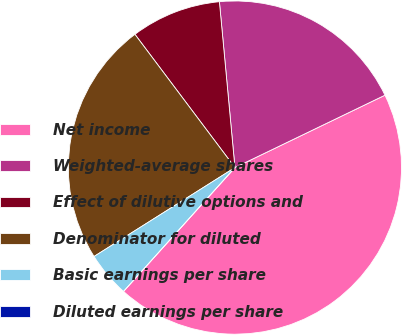Convert chart. <chart><loc_0><loc_0><loc_500><loc_500><pie_chart><fcel>Net income<fcel>Weighted-average shares<fcel>Effect of dilutive options and<fcel>Denominator for diluted<fcel>Basic earnings per share<fcel>Diluted earnings per share<nl><fcel>43.81%<fcel>19.33%<fcel>8.76%<fcel>23.71%<fcel>4.38%<fcel>0.0%<nl></chart> 